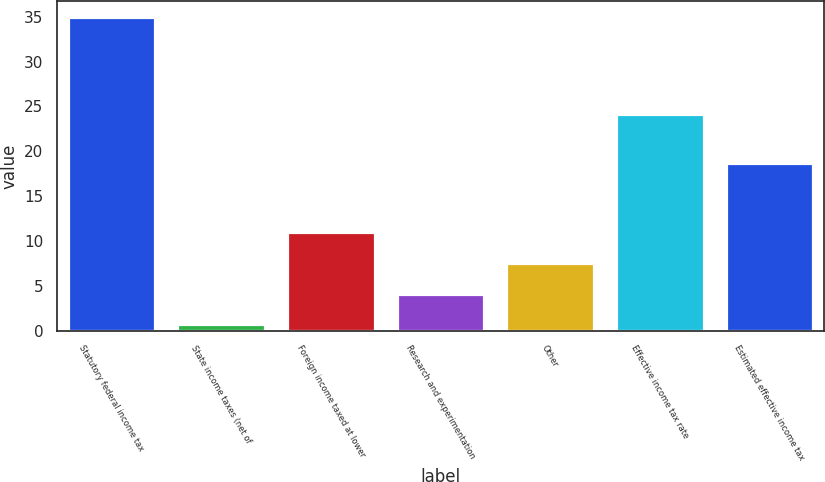Convert chart. <chart><loc_0><loc_0><loc_500><loc_500><bar_chart><fcel>Statutory federal income tax<fcel>State income taxes (net of<fcel>Foreign income taxed at lower<fcel>Research and experimentation<fcel>Other<fcel>Effective income tax rate<fcel>Estimated effective income tax<nl><fcel>35<fcel>0.7<fcel>10.99<fcel>4.13<fcel>7.56<fcel>24.2<fcel>18.7<nl></chart> 